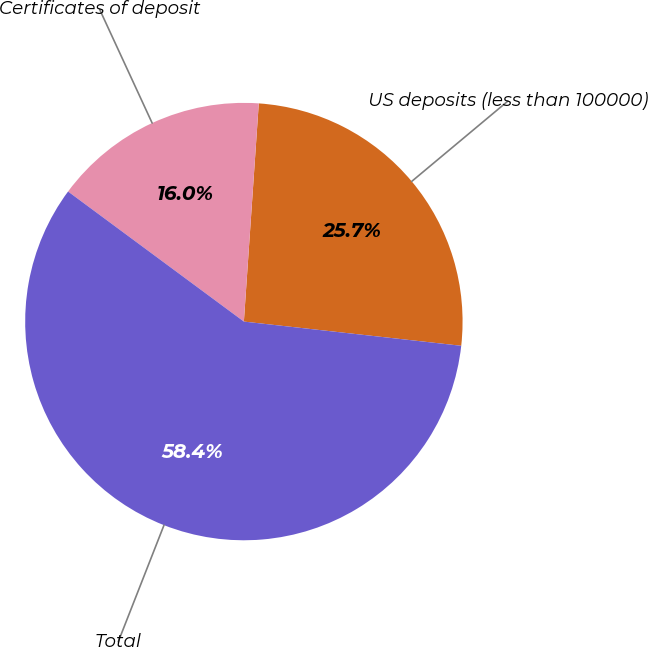<chart> <loc_0><loc_0><loc_500><loc_500><pie_chart><fcel>US deposits (less than 100000)<fcel>Certificates of deposit<fcel>Total<nl><fcel>25.68%<fcel>15.95%<fcel>58.37%<nl></chart> 